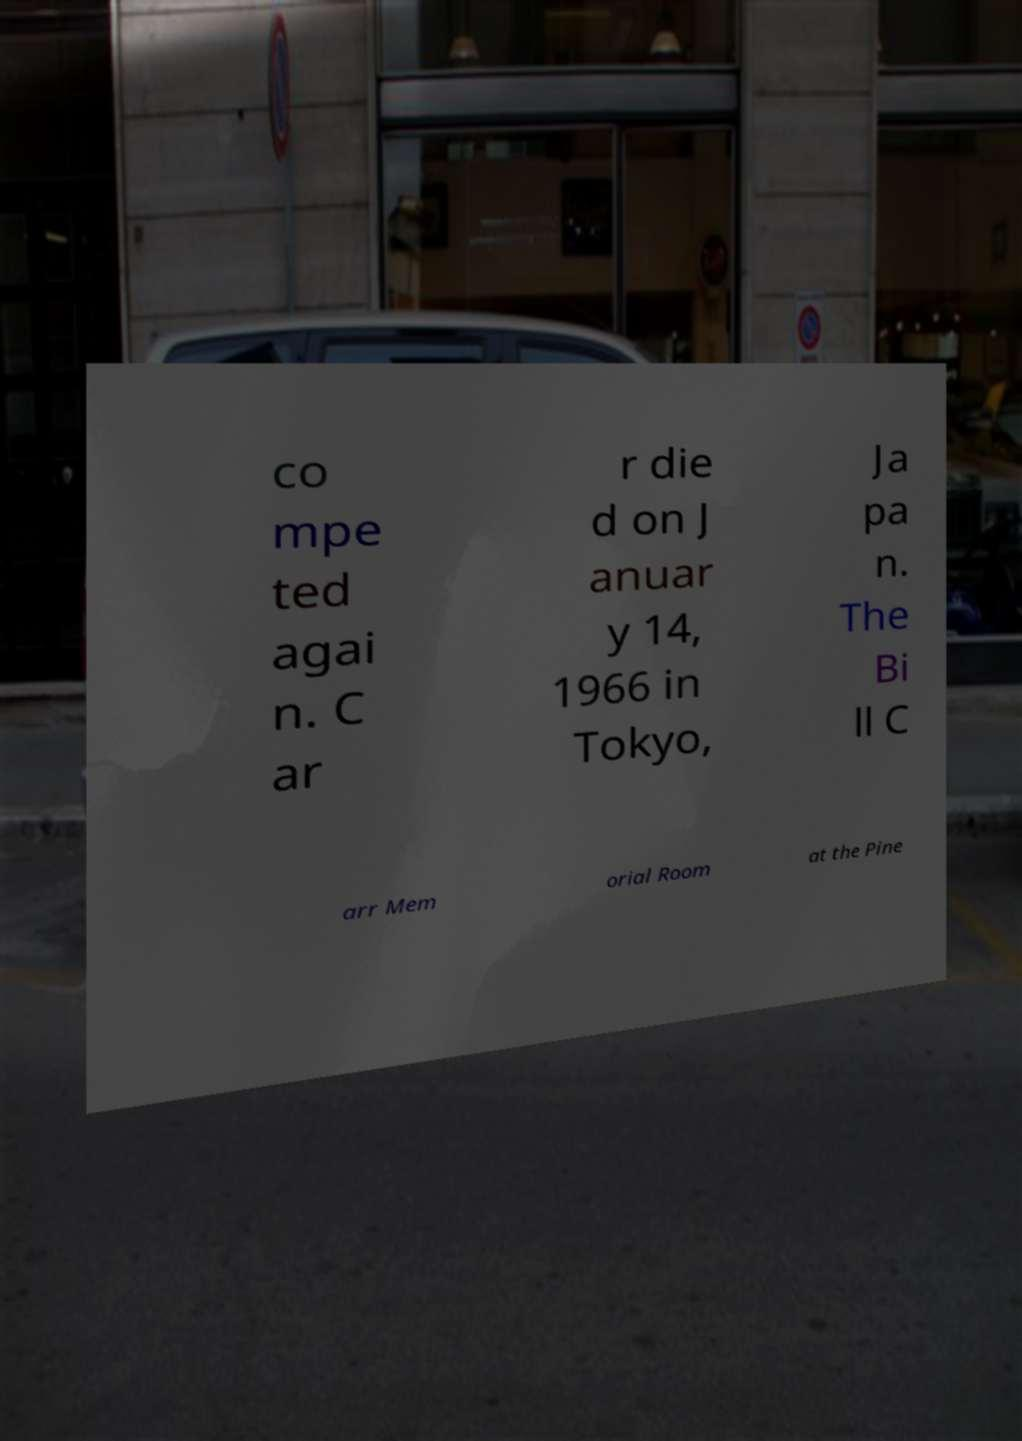Could you extract and type out the text from this image? co mpe ted agai n. C ar r die d on J anuar y 14, 1966 in Tokyo, Ja pa n. The Bi ll C arr Mem orial Room at the Pine 